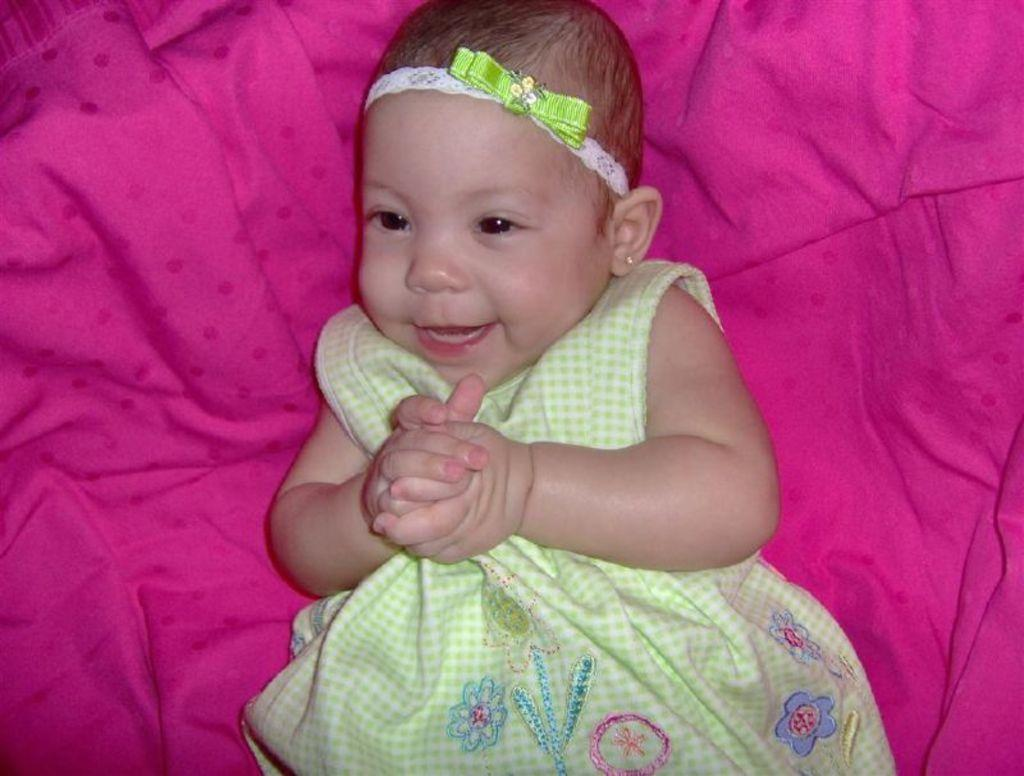What is the main subject of the image? There is a baby in the image. What is the baby wearing? The baby is wearing clothes. Are there any accessories visible on the baby? Yes, the baby has ear studs. What is the baby lying on? The baby is lying on a pink cloth. What is the name of the baby's son in the image? There is no son present in the image, as the baby is the main subject. How many clovers can be seen near the baby in the image? There are no clovers visible in the image. 